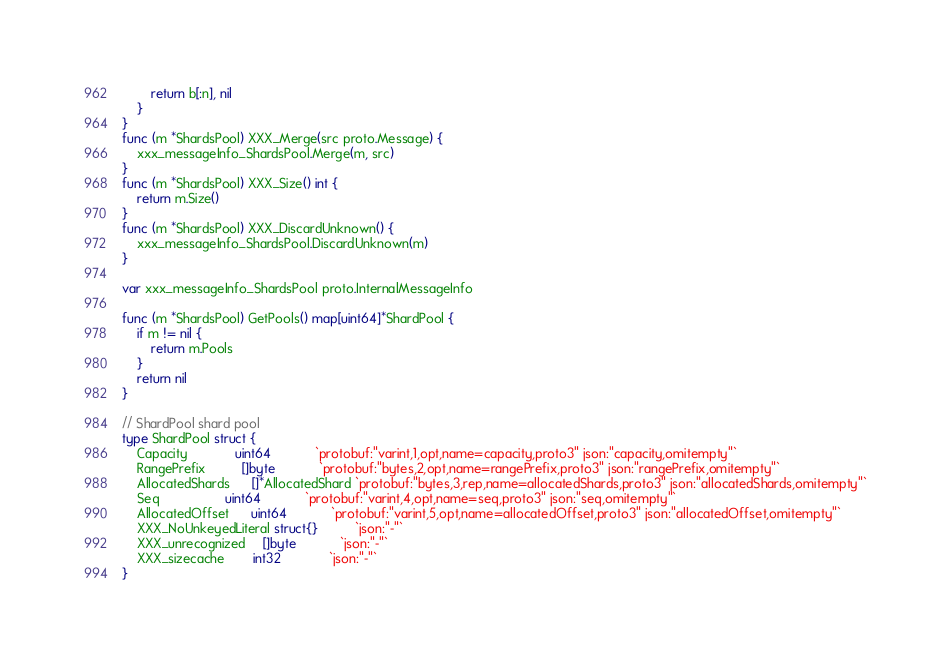<code> <loc_0><loc_0><loc_500><loc_500><_Go_>		return b[:n], nil
	}
}
func (m *ShardsPool) XXX_Merge(src proto.Message) {
	xxx_messageInfo_ShardsPool.Merge(m, src)
}
func (m *ShardsPool) XXX_Size() int {
	return m.Size()
}
func (m *ShardsPool) XXX_DiscardUnknown() {
	xxx_messageInfo_ShardsPool.DiscardUnknown(m)
}

var xxx_messageInfo_ShardsPool proto.InternalMessageInfo

func (m *ShardsPool) GetPools() map[uint64]*ShardPool {
	if m != nil {
		return m.Pools
	}
	return nil
}

// ShardPool shard pool
type ShardPool struct {
	Capacity             uint64            `protobuf:"varint,1,opt,name=capacity,proto3" json:"capacity,omitempty"`
	RangePrefix          []byte            `protobuf:"bytes,2,opt,name=rangePrefix,proto3" json:"rangePrefix,omitempty"`
	AllocatedShards      []*AllocatedShard `protobuf:"bytes,3,rep,name=allocatedShards,proto3" json:"allocatedShards,omitempty"`
	Seq                  uint64            `protobuf:"varint,4,opt,name=seq,proto3" json:"seq,omitempty"`
	AllocatedOffset      uint64            `protobuf:"varint,5,opt,name=allocatedOffset,proto3" json:"allocatedOffset,omitempty"`
	XXX_NoUnkeyedLiteral struct{}          `json:"-"`
	XXX_unrecognized     []byte            `json:"-"`
	XXX_sizecache        int32             `json:"-"`
}
</code> 